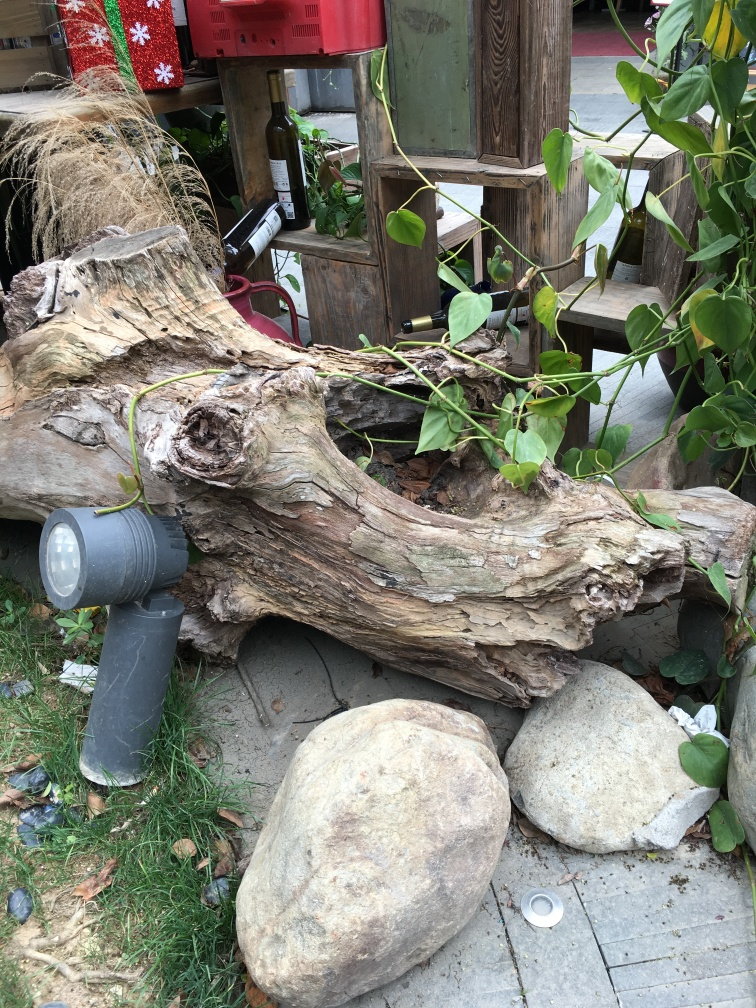What are some notable features in this outdoor scene? The photo captures an eclectic outdoor setting with a rustic, weathered log in the foreground, accompanied by large stones and green plants. There's also an intriguing wooden structure in the background holding bottles, possibly part of a creative decorative piece or practical storage arrangement. Does this arrangement serve a functional purpose or is it purely decorative? While the primary function is not immediately clear, it seems to be a blend of both practicality and decor. The bottles may indicate a unique outdoor wine storage concept, while the log, plants, and stones add an aesthetic natural touch to the space. 